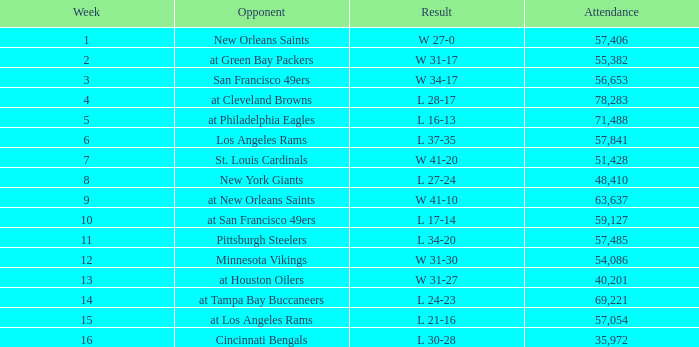What was the mean attendance figure for the game played following the 13th week on november 29, 1981? None. 